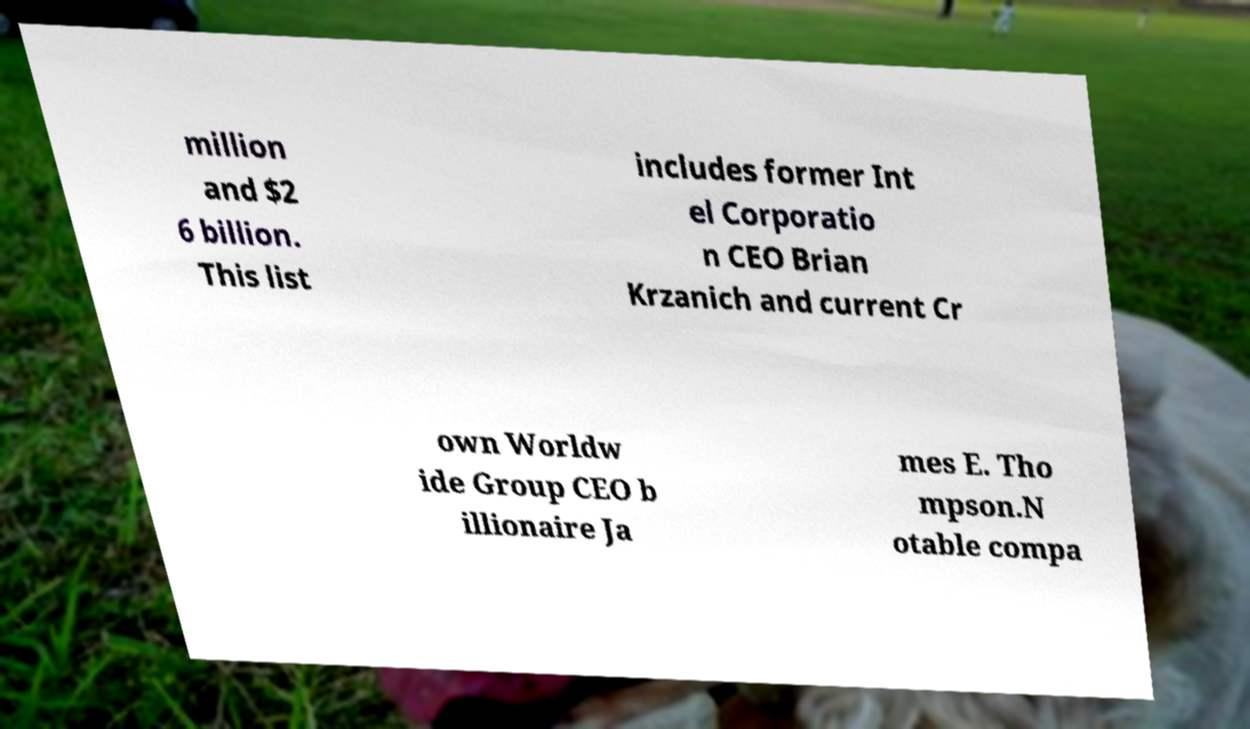Please read and relay the text visible in this image. What does it say? million and $2 6 billion. This list includes former Int el Corporatio n CEO Brian Krzanich and current Cr own Worldw ide Group CEO b illionaire Ja mes E. Tho mpson.N otable compa 